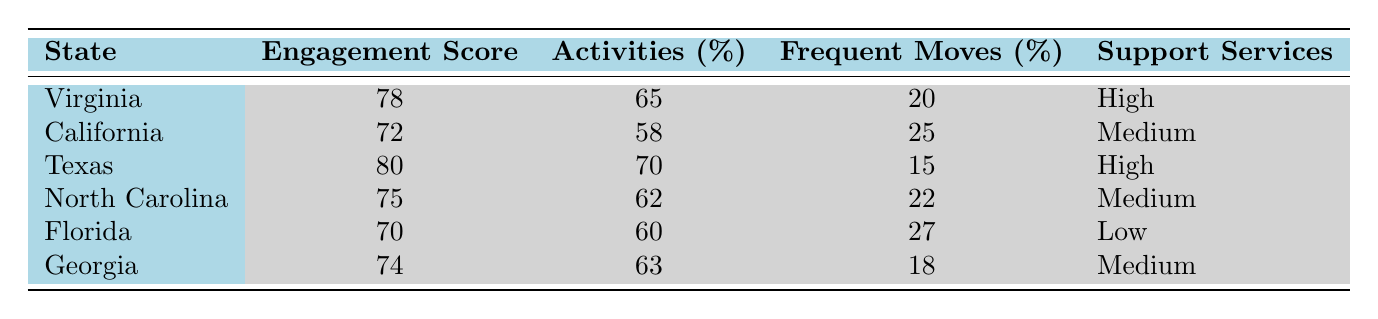What is the average engagement score for North Carolina? The engagement score for North Carolina is directly provided in the table as 75.
Answer: 75 Which state has the highest clubs and activities participation rate? Texas has the highest participation rate at 70%, which is greater than the rates of other states listed.
Answer: Texas Is the supportive services availability in Florida low? Yes, the table states that Florida has a low availability of supportive services.
Answer: Yes What is the difference in the average engagement score between Texas and California? Texas has an average engagement score of 80, while California has a score of 72. The difference is calculated as 80 - 72 = 8.
Answer: 8 How many states have a support services availability rated as Medium? From the table, California, North Carolina, and Georgia are listed with Medium availability, making a total of three states.
Answer: 3 Calculate the average clubs and activities participation rate across all listed states. To find the average, sum the participation rates (65 + 58 + 70 + 62 + 60 + 63 = 408) and divide by the number of states (6). The average is 408 / 6 = 68.
Answer: 68 Is there a correlation between average engagement scores and supportive services availability? Yes, both Virginia and Texas have high engagement scores and high supportive services availability, while Florida has a low engagement score and low supportive services availability. This suggests a positive correlation.
Answer: Yes What percentage of students frequently move in Florida? The table indicates that 27% of students in Florida frequently move.
Answer: 27% 